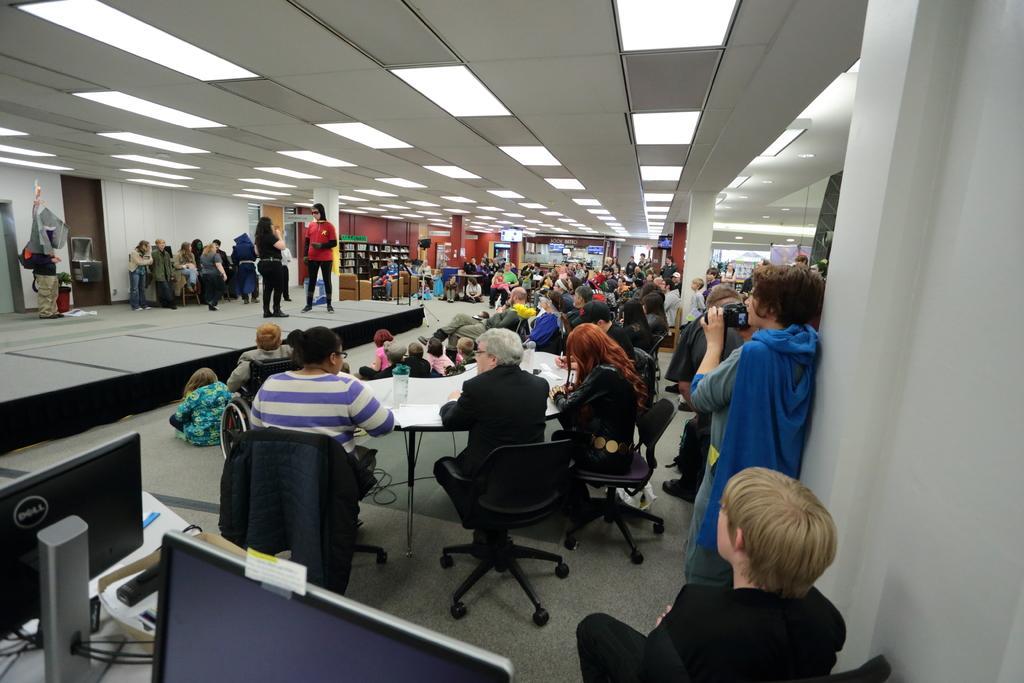Could you give a brief overview of what you see in this image? Here in this picture we can see a group of people sitting on chairs with table in front of them and some group of people are standing here and there , in the bottom left we can see monitors present on a table and there are lights on the top present 